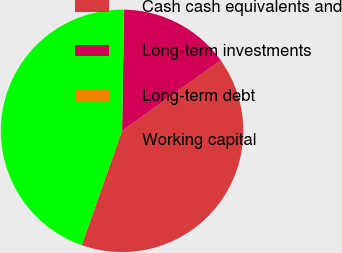Convert chart to OTSL. <chart><loc_0><loc_0><loc_500><loc_500><pie_chart><fcel>Cash cash equivalents and<fcel>Long-term investments<fcel>Long-term debt<fcel>Working capital<nl><fcel>40.3%<fcel>14.84%<fcel>0.02%<fcel>44.84%<nl></chart> 